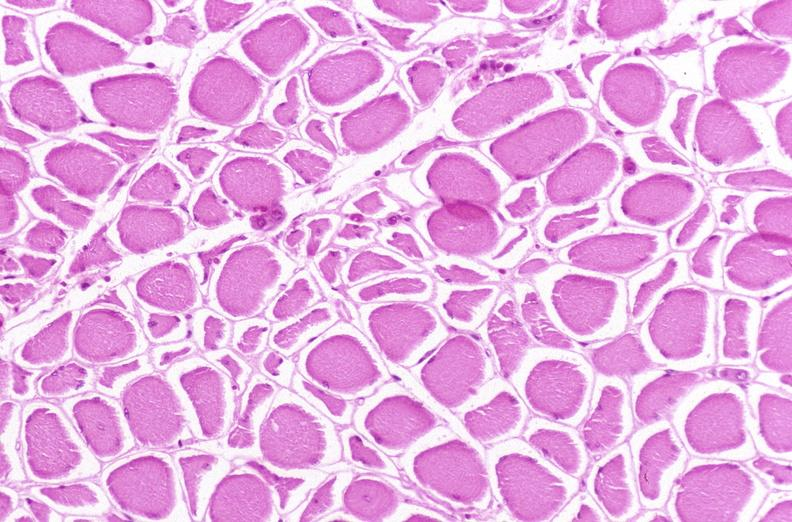does esophagus show skeletal muscle, atrophy due to immobilization cast?
Answer the question using a single word or phrase. No 